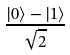<formula> <loc_0><loc_0><loc_500><loc_500>\frac { | 0 \rangle - | 1 \rangle } { \sqrt { 2 } }</formula> 